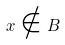Convert formula to latex. <formula><loc_0><loc_0><loc_500><loc_500>x \notin B</formula> 